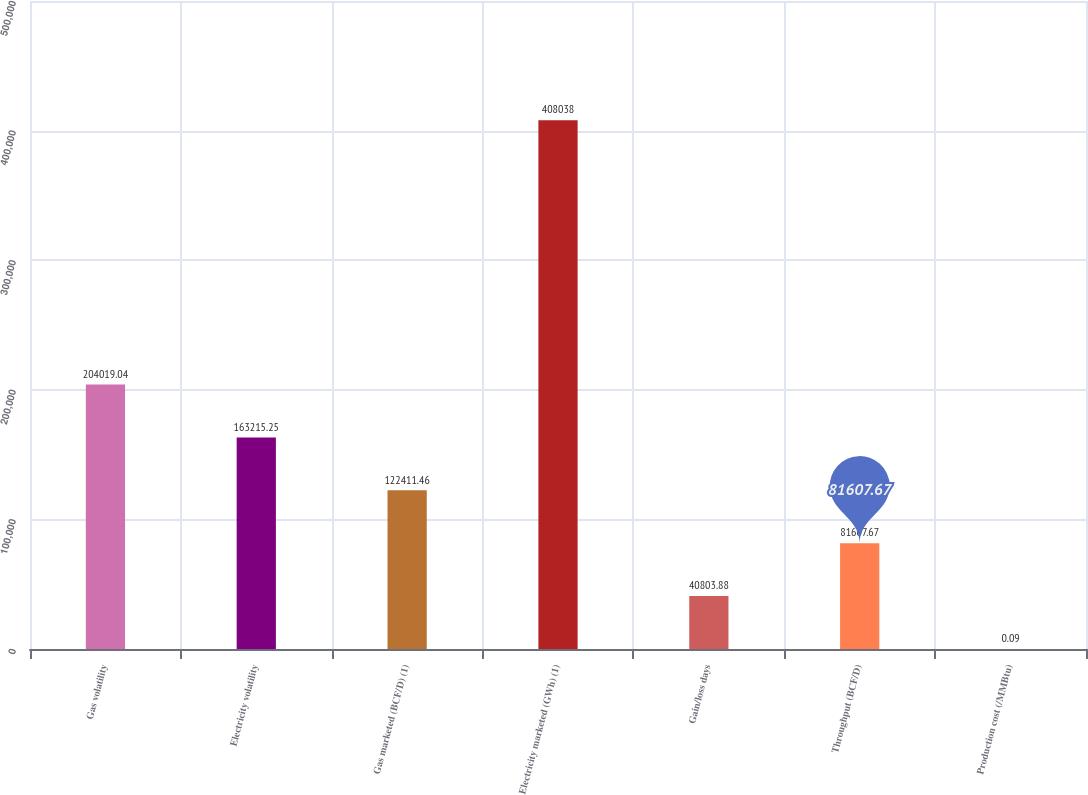<chart> <loc_0><loc_0><loc_500><loc_500><bar_chart><fcel>Gas volatility<fcel>Electricity volatility<fcel>Gas marketed (BCF/D) (1)<fcel>Electricity marketed (GWh) (1)<fcel>Gain/loss days<fcel>Throughput (BCF/D)<fcel>Production cost (/MMBtu)<nl><fcel>204019<fcel>163215<fcel>122411<fcel>408038<fcel>40803.9<fcel>81607.7<fcel>0.09<nl></chart> 